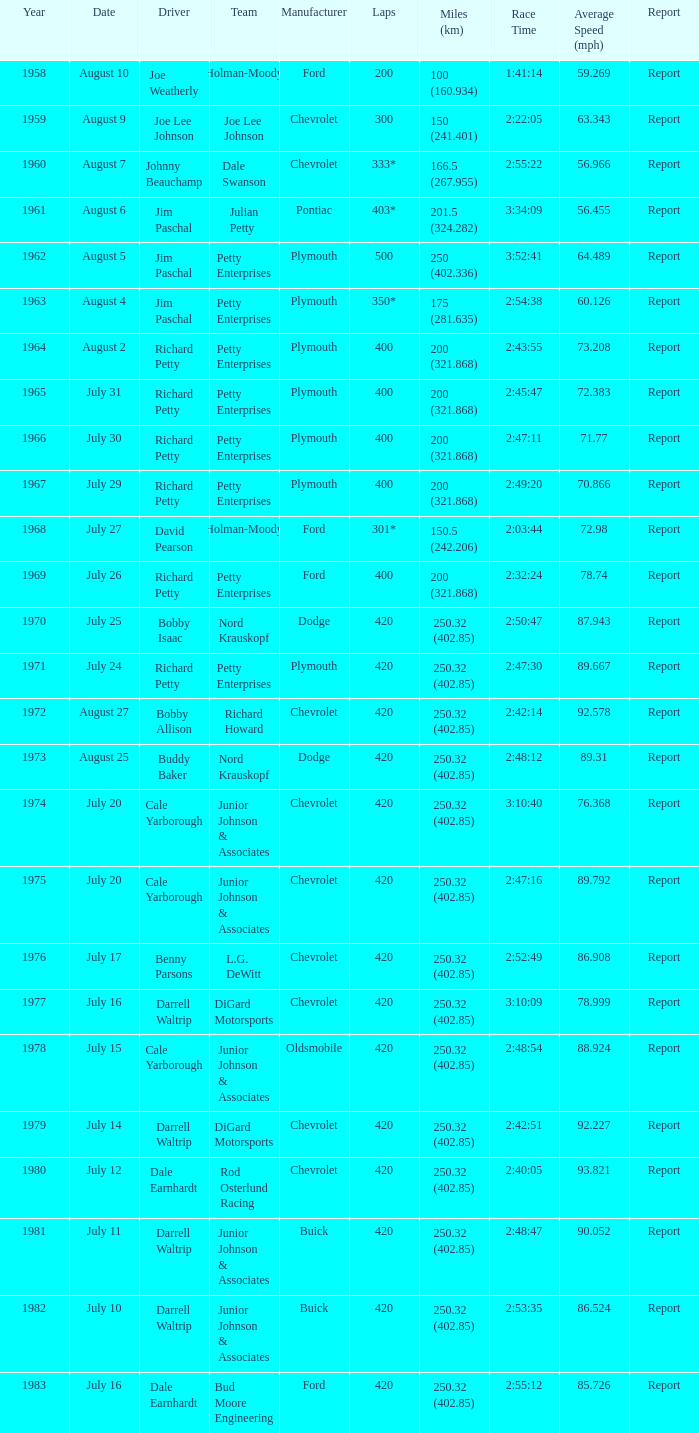What is the number of races cale yarborough won with an 88.924 mph average speed? 1.0. 